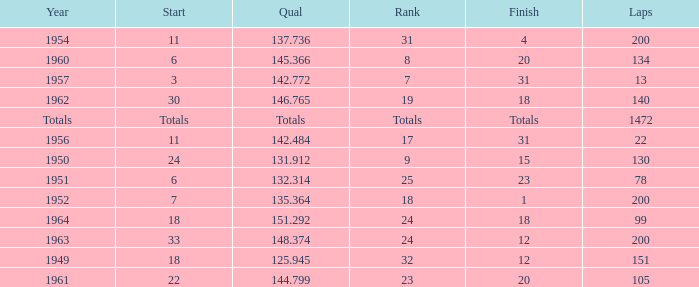Name the rank for laps less than 130 and year of 1951 25.0. 